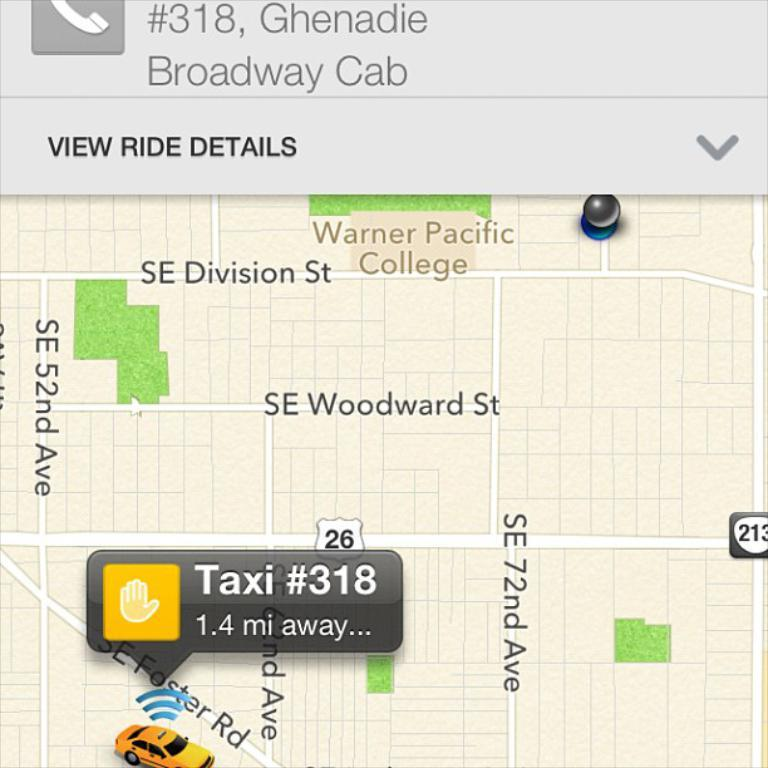<image>
Share a concise interpretation of the image provided. the word taxi on top of a map 